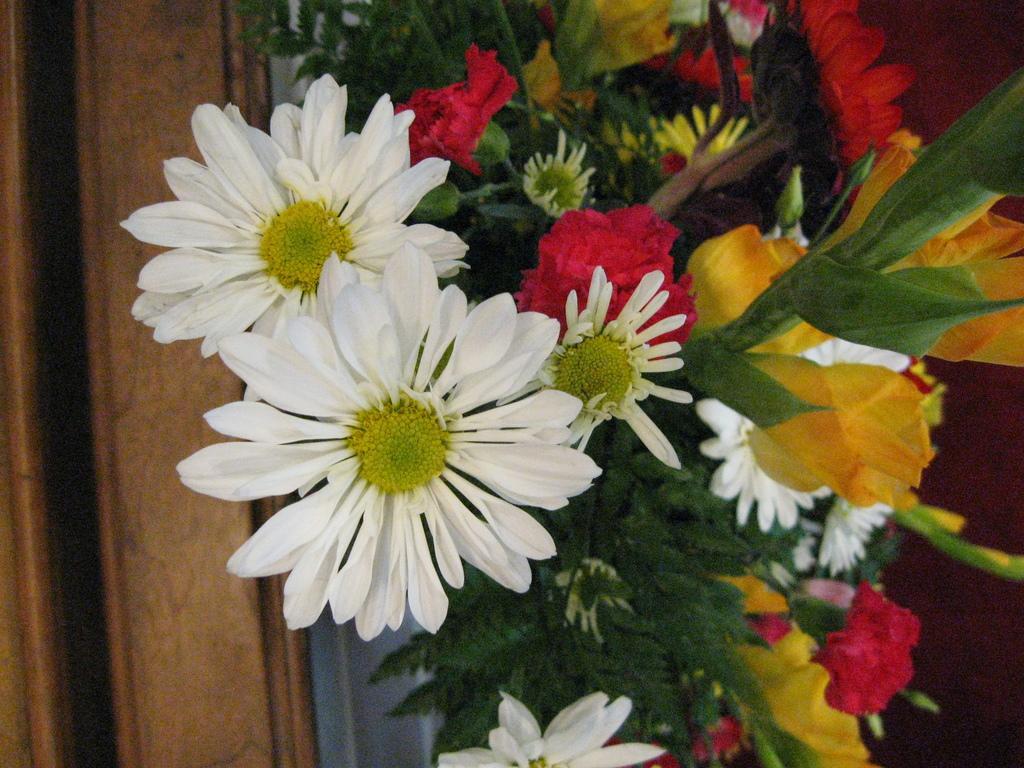Describe this image in one or two sentences. There are some white, red and yellow color flowers with leaves. On the left side we can see wood. 